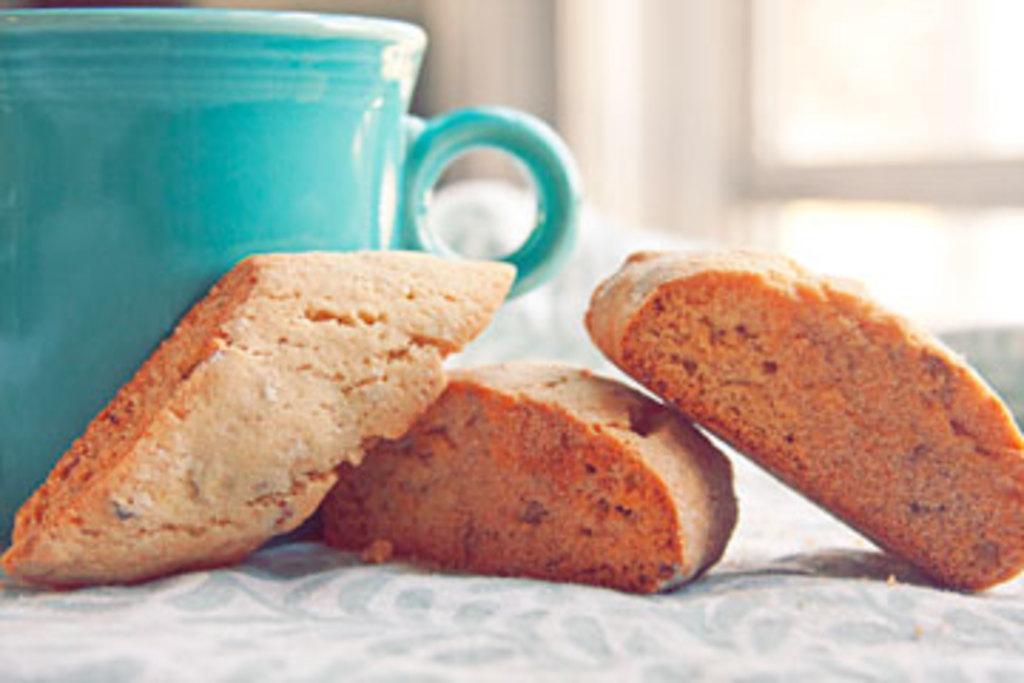Describe this image in one or two sentences. The picture consists of a table covered with cloth. On the table there are biscuits and a cup. The background is blurred. In the background there is a window and wall. 